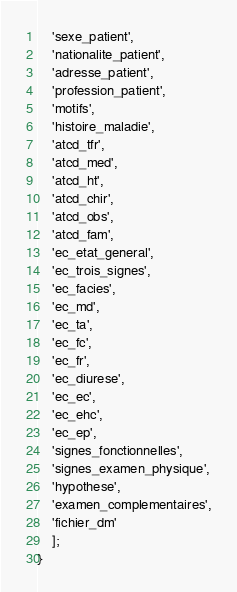Convert code to text. <code><loc_0><loc_0><loc_500><loc_500><_PHP_>    'sexe_patient',
    'nationalite_patient',
    'adresse_patient',
    'profession_patient',
    'motifs',
    'histoire_maladie',
    'atcd_tfr',
    'atcd_med',
    'atcd_ht',
    'atcd_chir',
    'atcd_obs',
    'atcd_fam',
    'ec_etat_general',
    'ec_trois_signes',
    'ec_facies',
    'ec_md',
    'ec_ta',
    'ec_fc',
    'ec_fr',
    'ec_diurese',
    'ec_ec',
    'ec_ehc',
    'ec_ep',
    'signes_fonctionnelles',
    'signes_examen_physique',
    'hypothese',
    'examen_complementaires',
    'fichier_dm'
    ];
}
</code> 